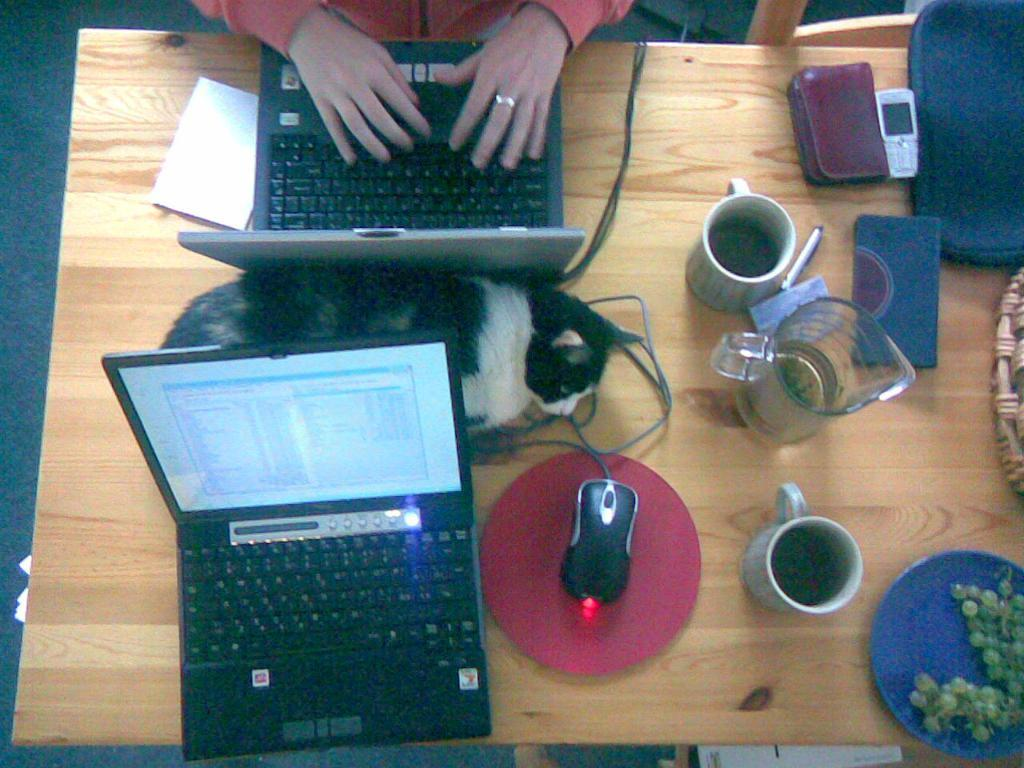What type of animal can be seen in the image? There is a cat in the image. What is the cat doing in the image? The cat is sleeping. Where is the cat located in relation to the laptops? The cat is between two laptops. What other objects can be seen on the table in the image? There is a mouse, cups, a jar, mobile phones, plates, and fruits on the table. What type of apple can be seen growing on the sand in the image? There is no apple or sand present in the image. How many nails can be seen holding the cat's paws in the image? There are no nails present in the image, and the cat's paws are not being held by any object. 